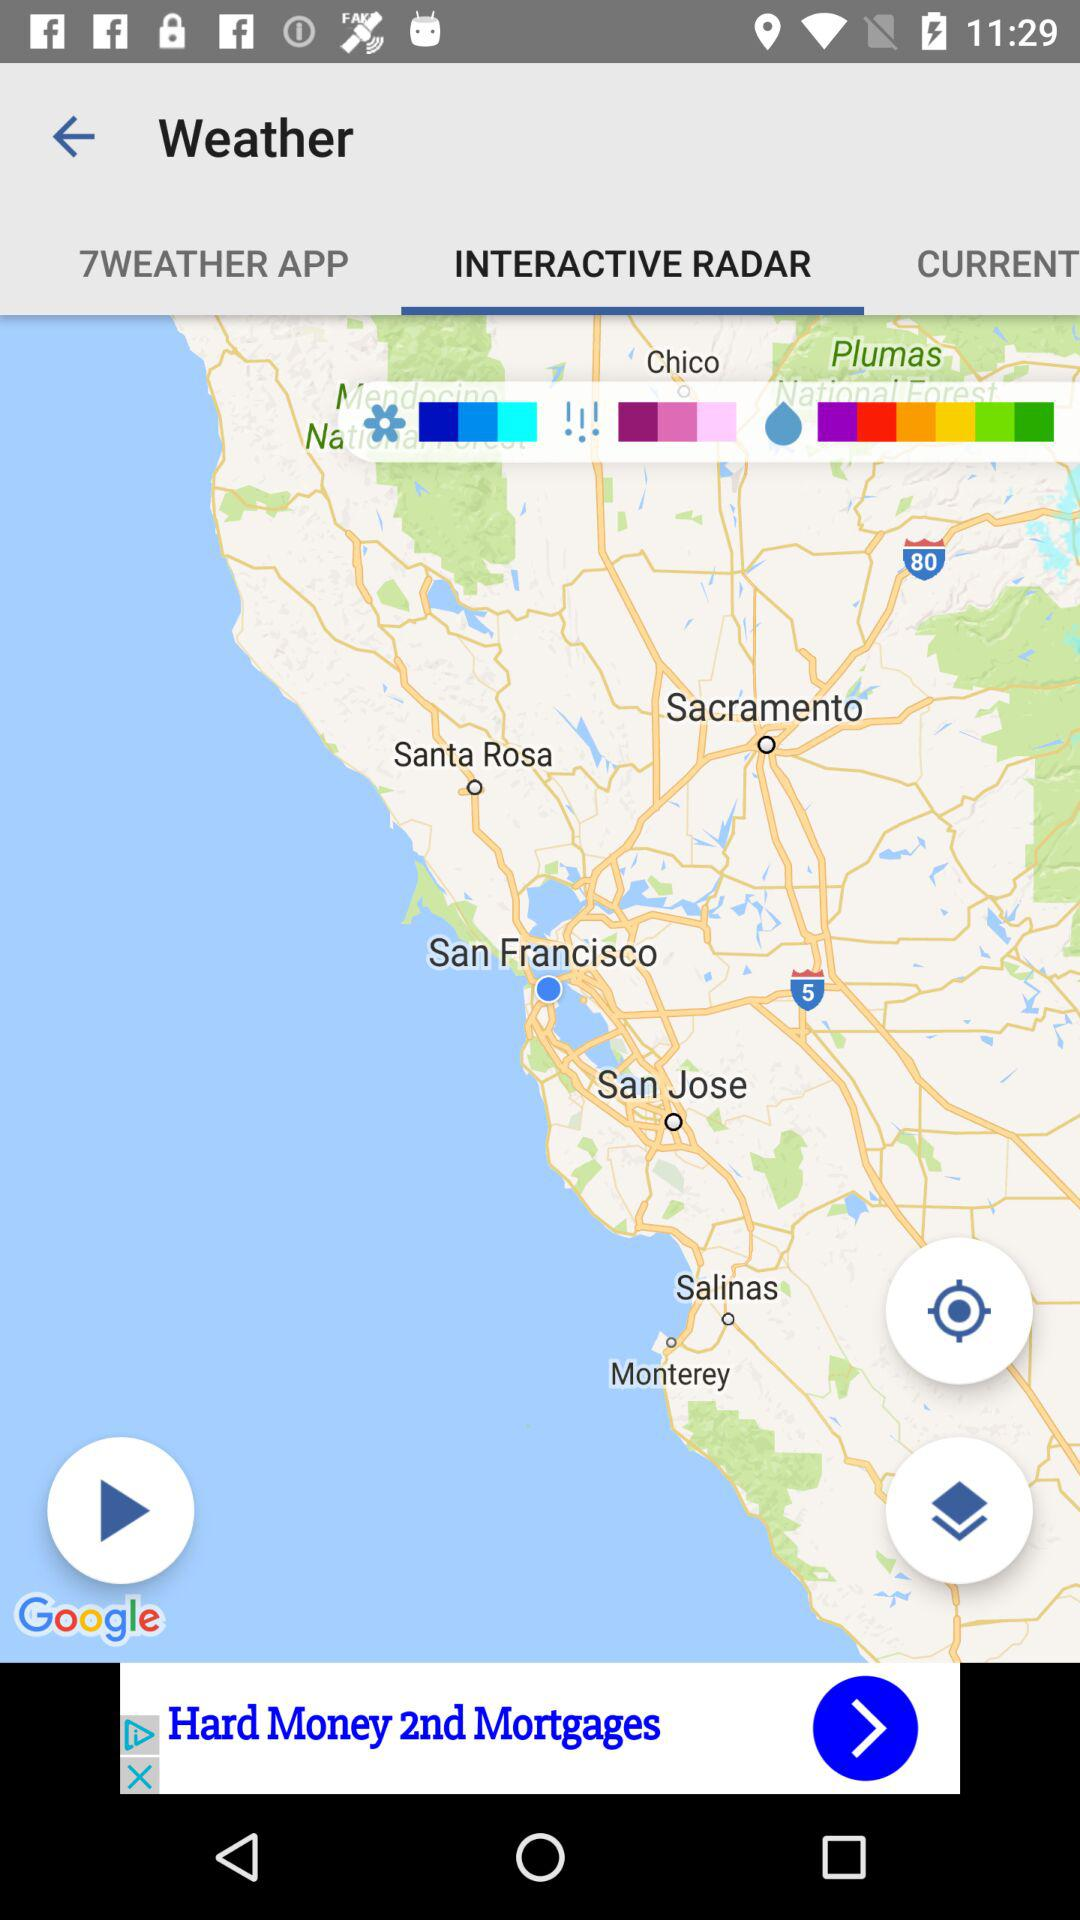What is the selected tab? The selected tab is "INTERACTIVE RADAR". 